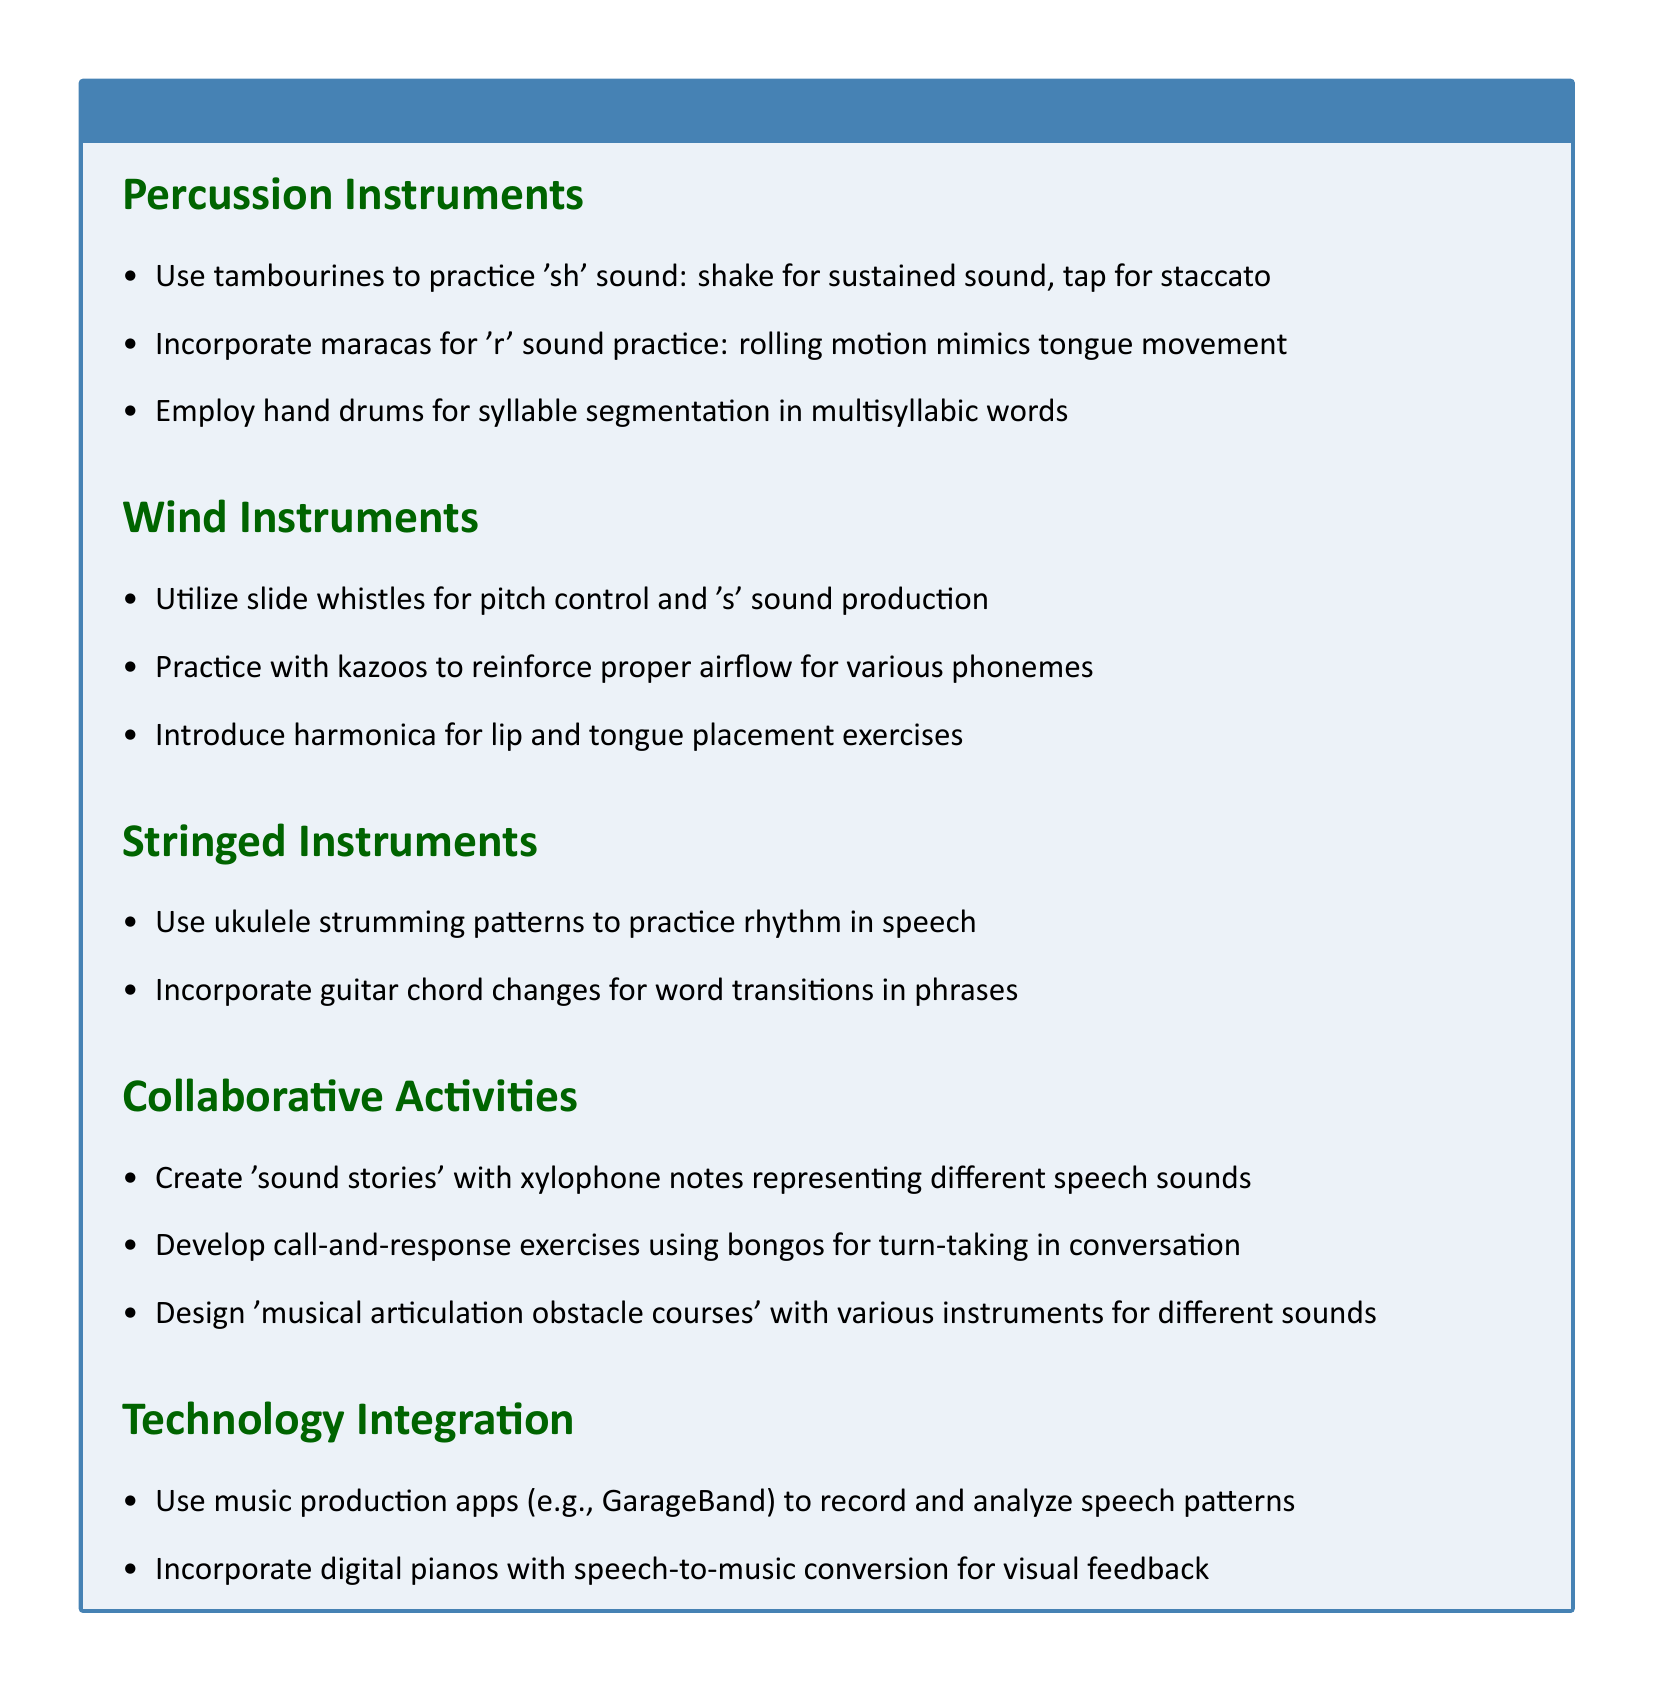What instrument can be used to practice the 'sh' sound? The document states that tambourines can be used to practice the 'sh' sound.
Answer: tambourines Which wind instrument helps with proper airflow for phonemes? The document mentions that kazoos reinforce proper airflow for various phonemes.
Answer: kazoos How many collaborative activities are listed in the document? The document lists three collaborative activities under that section.
Answer: 3 What is one string instrument mentioned for practicing rhythm in speech? The ukulele is mentioned as an instrument for practicing rhythm in speech.
Answer: ukulele What type of instruments are used for syllable segmentation in multisyllabic words? Hand drums are employed for syllable segmentation in multisyllabic words.
Answer: hand drums What activity involves xylophone notes representing different speech sounds? The document describes creating 'sound stories' with xylophone notes to represent different speech sounds.
Answer: sound stories What technology is suggested for recording and analyzing speech patterns? Music production apps like GarageBand are suggested for this purpose.
Answer: GarageBand Which section focuses on instruments that require blowing air? The section that focuses on instruments requiring blowing air is the Wind Instruments section.
Answer: Wind Instruments 